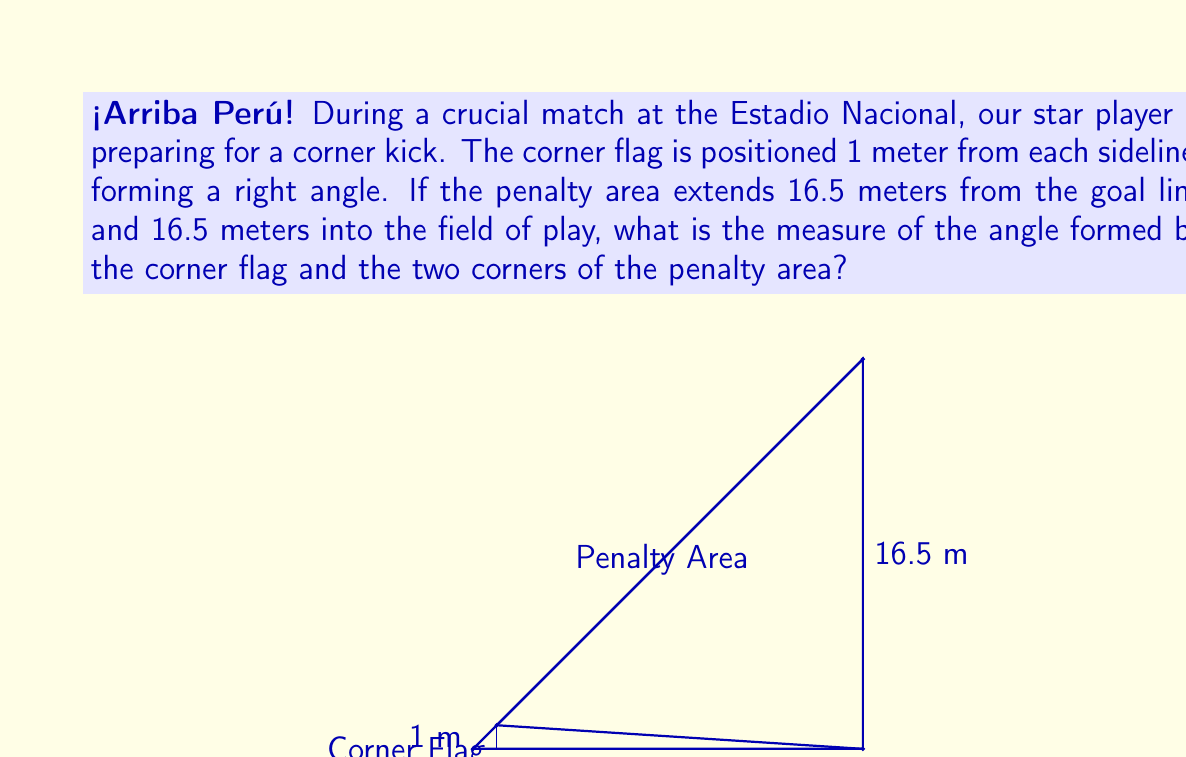Give your solution to this math problem. Let's approach this step-by-step:

1) First, we need to identify the triangle formed by the corner flag and the two corners of the penalty area. This is a right-angled triangle.

2) We know that the corner flag is 1 meter from each sideline, so it forms a small square in the corner. The hypotenuse of this square is the starting point of our larger triangle.

3) To find the length of this hypotenuse, we can use the Pythagorean theorem:
   $\sqrt{1^2 + 1^2} = \sqrt{2}$ meters

4) Now, for our larger triangle, we know two sides:
   - The base: 16.5 meters (width of penalty area)
   - The height: 16.5 meters (length of penalty area)

5) We can find the hypotenuse of this larger triangle using the Pythagorean theorem:
   $\sqrt{16.5^2 + 16.5^2} = \sqrt{544.5} = 23.33$ meters (rounded to 2 decimal places)

6) Now we have a triangle with sides:
   - $\sqrt{2}$ meters (from corner flag to penalty area corner)
   - 23.33 meters (across the penalty area)
   - 23.33 meters (across the penalty area)

7) This is an isosceles triangle. To find the angle at the corner flag, we can use the cosine law:

   $\cos \theta = \frac{b^2 + c^2 - a^2}{2bc}$

   Where $a$ is the side opposite to the angle we're looking for, and $b$ and $c$ are the equal sides.

8) Plugging in our values:

   $\cos \theta = \frac{23.33^2 + 23.33^2 - (\sqrt{2})^2}{2(23.33)(23.33)}$

9) Simplifying:

   $\cos \theta = \frac{1087.6778 - 2}{1088.6778} = 0.9991$

10) To get the angle, we take the inverse cosine (arccos):

    $\theta = \arccos(0.9991) = 2.44$ degrees (rounded to 2 decimal places)
Answer: $2.44°$ 